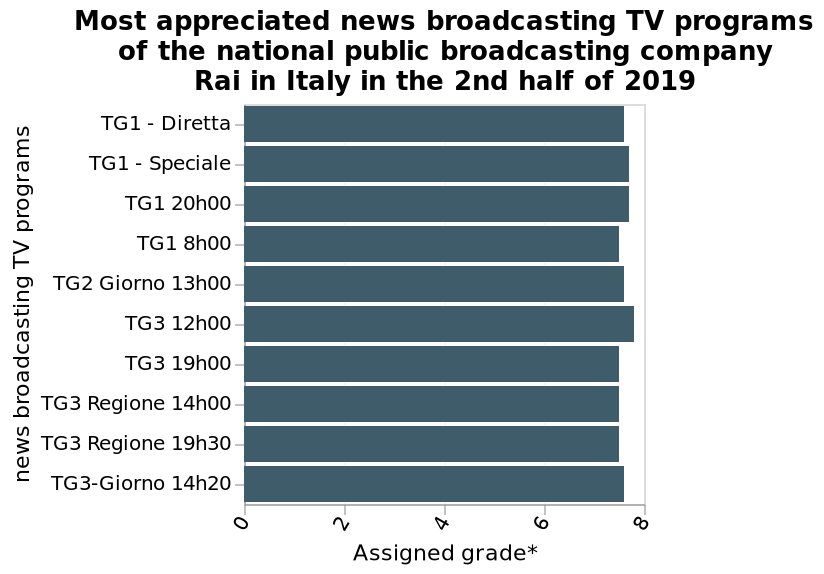<image>
Is there a significant difference in the level of appreciation between the options?  No, according to the description, there is only a small scale of variation in the level of appreciation between them. What is the range of the assigned grade on the x-axis? The range of the assigned grade on the x-axis is from 0 to 8. Offer a thorough analysis of the image. They all seem to be equally appreciated, with only a small scale of variation between them. 